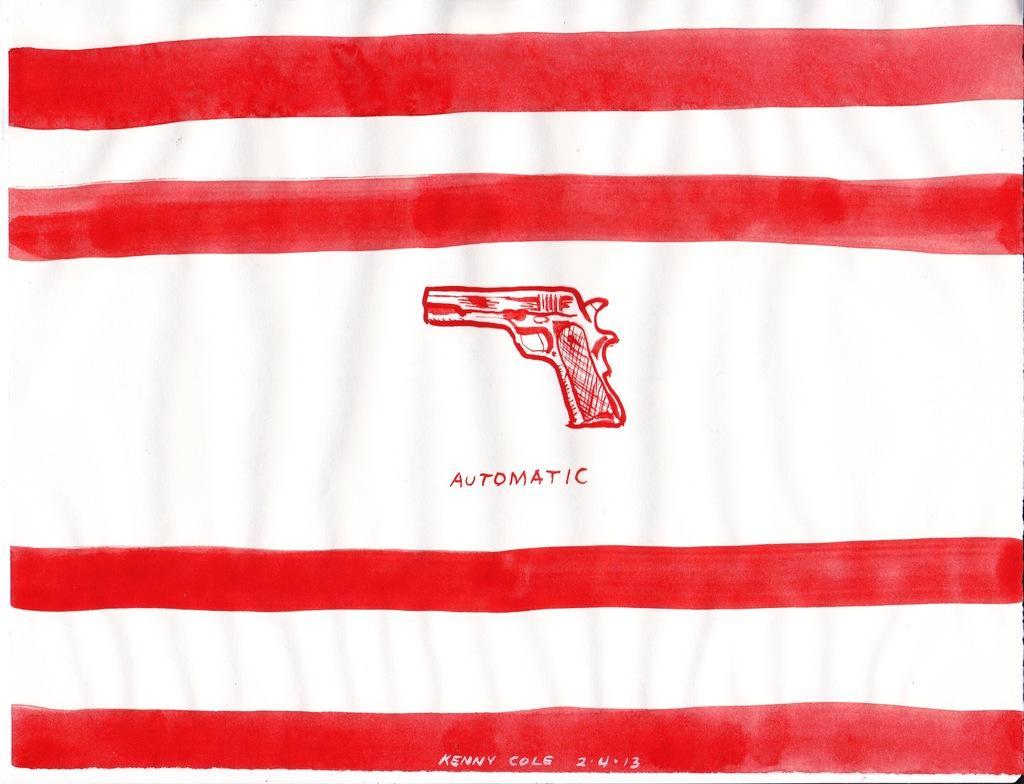How would you summarize this image in a sentence or two? Here I can see a white color flag. On this flag there are few red color lines, some text and a painting of a gun. 